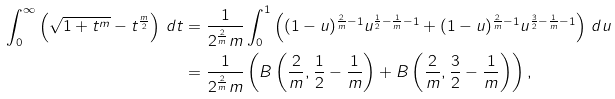<formula> <loc_0><loc_0><loc_500><loc_500>\int _ { 0 } ^ { \infty } \left ( \sqrt { 1 + t ^ { m } } - t ^ { \frac { m } { 2 } } \right ) \, d t & = \frac { 1 } { 2 ^ { \frac { 2 } { m } } m } \int _ { 0 } ^ { 1 } \left ( ( 1 - u ) ^ { \frac { 2 } { m } - 1 } u ^ { \frac { 1 } { 2 } - \frac { 1 } { m } - 1 } + ( 1 - u ) ^ { \frac { 2 } { m } - 1 } u ^ { \frac { 3 } { 2 } - \frac { 1 } { m } - 1 } \right ) \, d u \\ & = \frac { 1 } { 2 ^ { \frac { 2 } { m } } m } \left ( B \left ( \frac { 2 } { m } , \frac { 1 } { 2 } - \frac { 1 } { m } \right ) + B \left ( \frac { 2 } { m } , \frac { 3 } { 2 } - \frac { 1 } { m } \right ) \right ) ,</formula> 